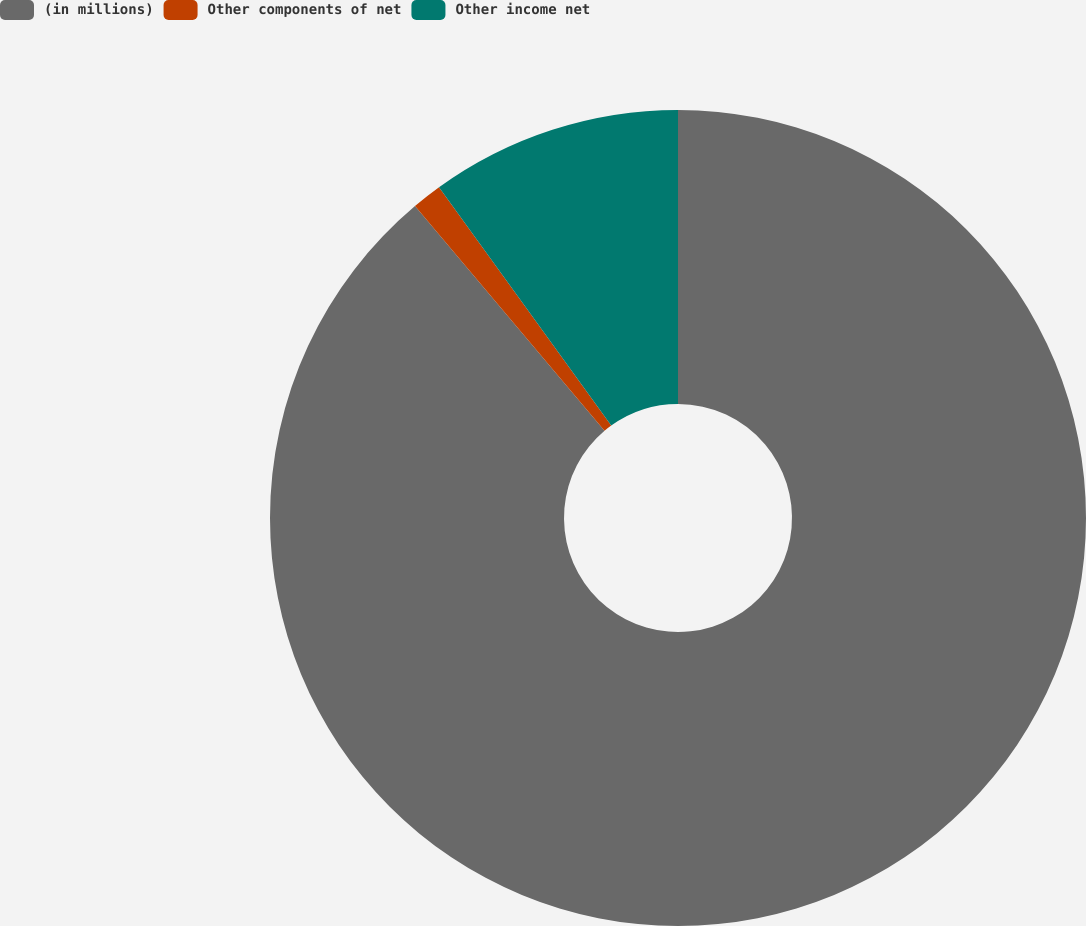Convert chart. <chart><loc_0><loc_0><loc_500><loc_500><pie_chart><fcel>(in millions)<fcel>Other components of net<fcel>Other income net<nl><fcel>88.85%<fcel>1.19%<fcel>9.96%<nl></chart> 